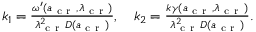Convert formula to latex. <formula><loc_0><loc_0><loc_500><loc_500>\begin{array} { r } { k _ { 1 } = \frac { \omega ^ { \prime } ( a _ { c r } , \lambda _ { c r } ) } { \lambda _ { c r } ^ { 2 } D ( a _ { c r } ) } , \quad k _ { 2 } = \frac { k \gamma ( a _ { c r } , \lambda _ { c r } ) } { \lambda _ { c r } ^ { 2 } D ( a _ { c r } ) } . } \end{array}</formula> 